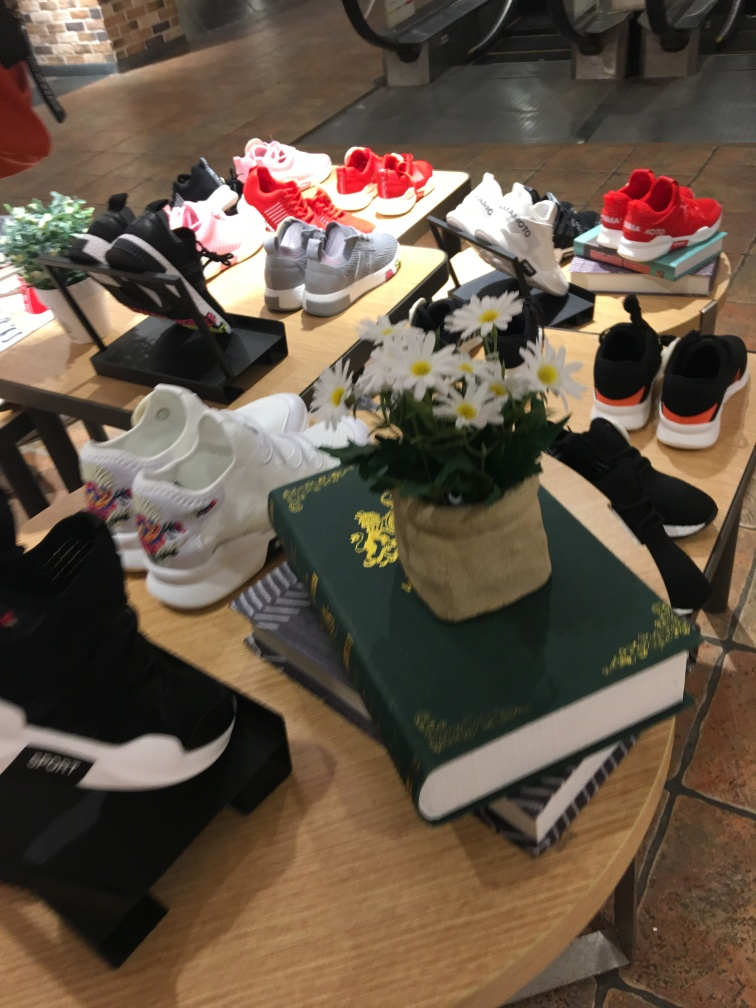What styles or types of shoes can be seen in the image? The image shows a display of various shoes including athletic sneakers, casual shoes, and what appear to be children's shoes in multiple colors. There's an array of designs showcasing different patterns, and a mix of vibrant and monochrome color schemes. 